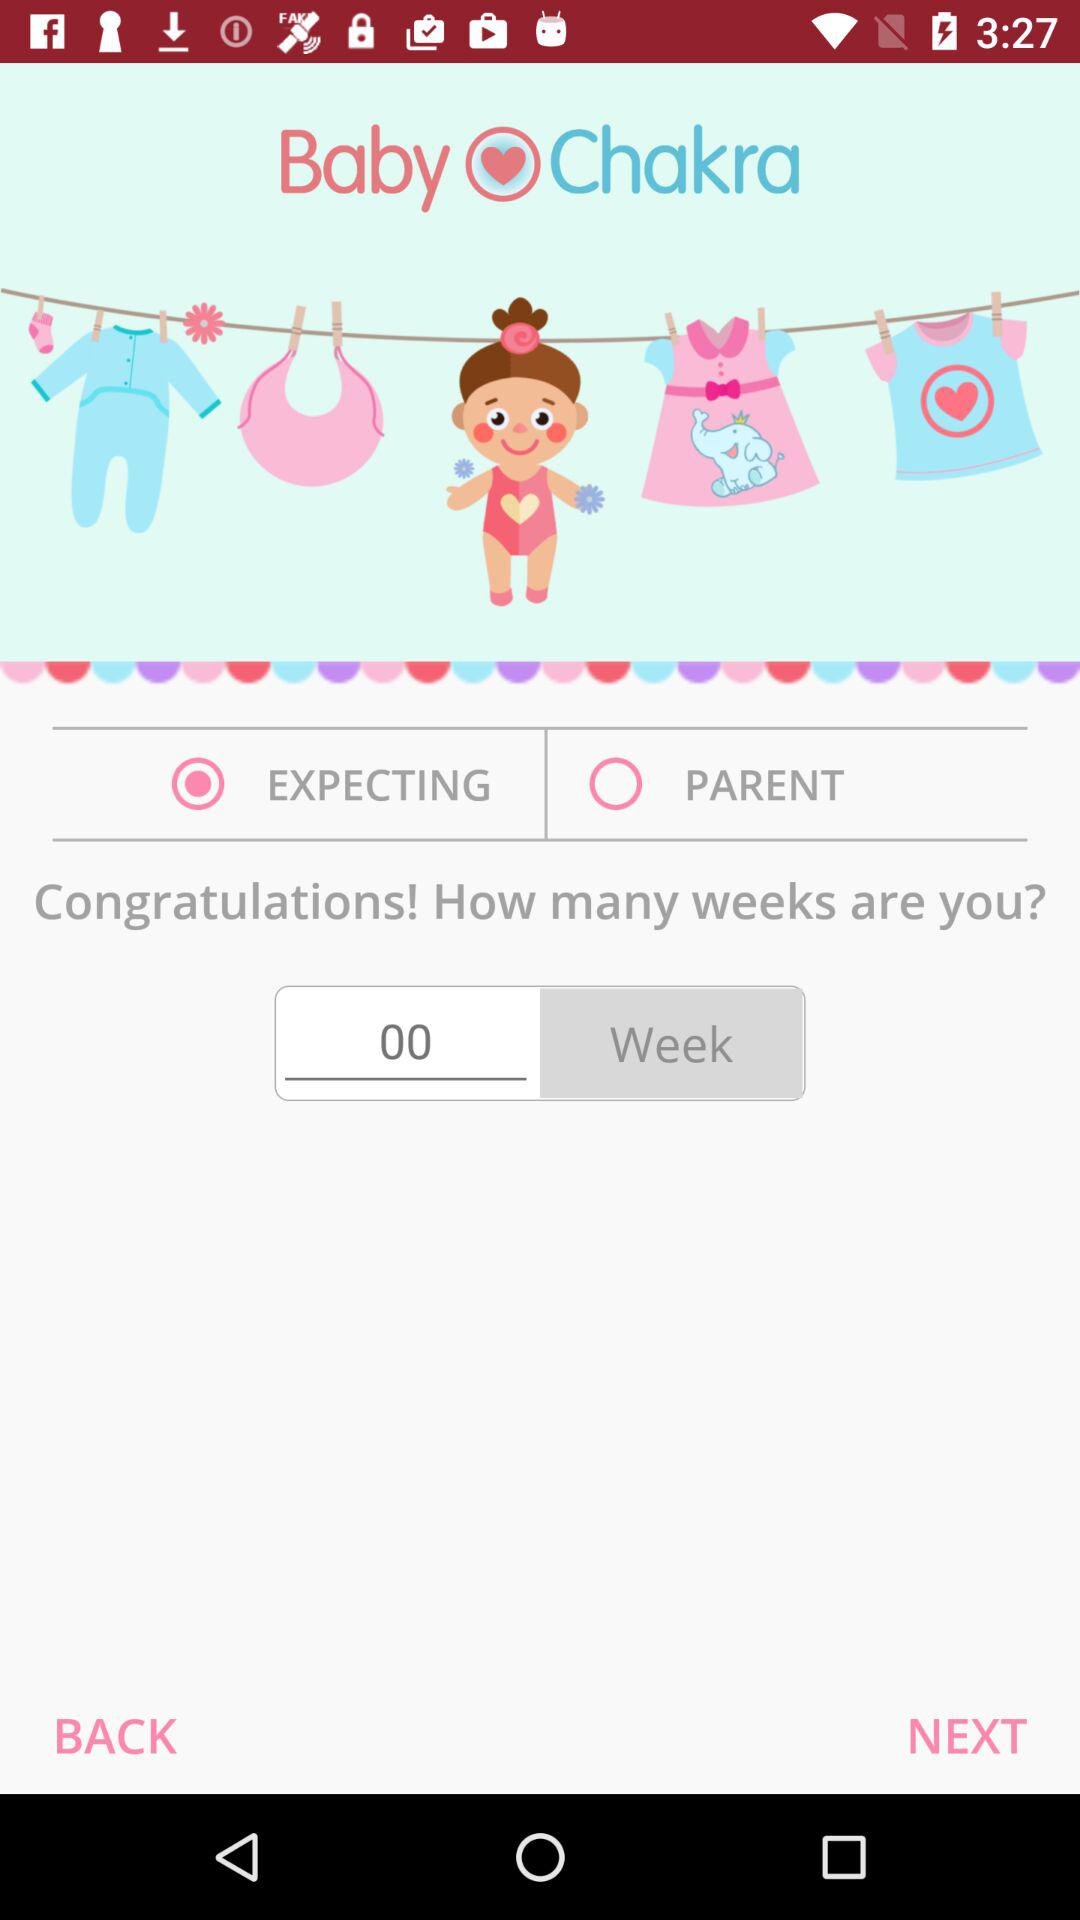Which is the selected option? The selected option is "EXPECTING". 